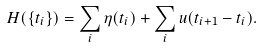Convert formula to latex. <formula><loc_0><loc_0><loc_500><loc_500>H ( \{ t _ { i } \} ) = \sum _ { i } \eta ( t _ { i } ) + \sum _ { i } u ( t _ { i + 1 } - t _ { i } ) .</formula> 